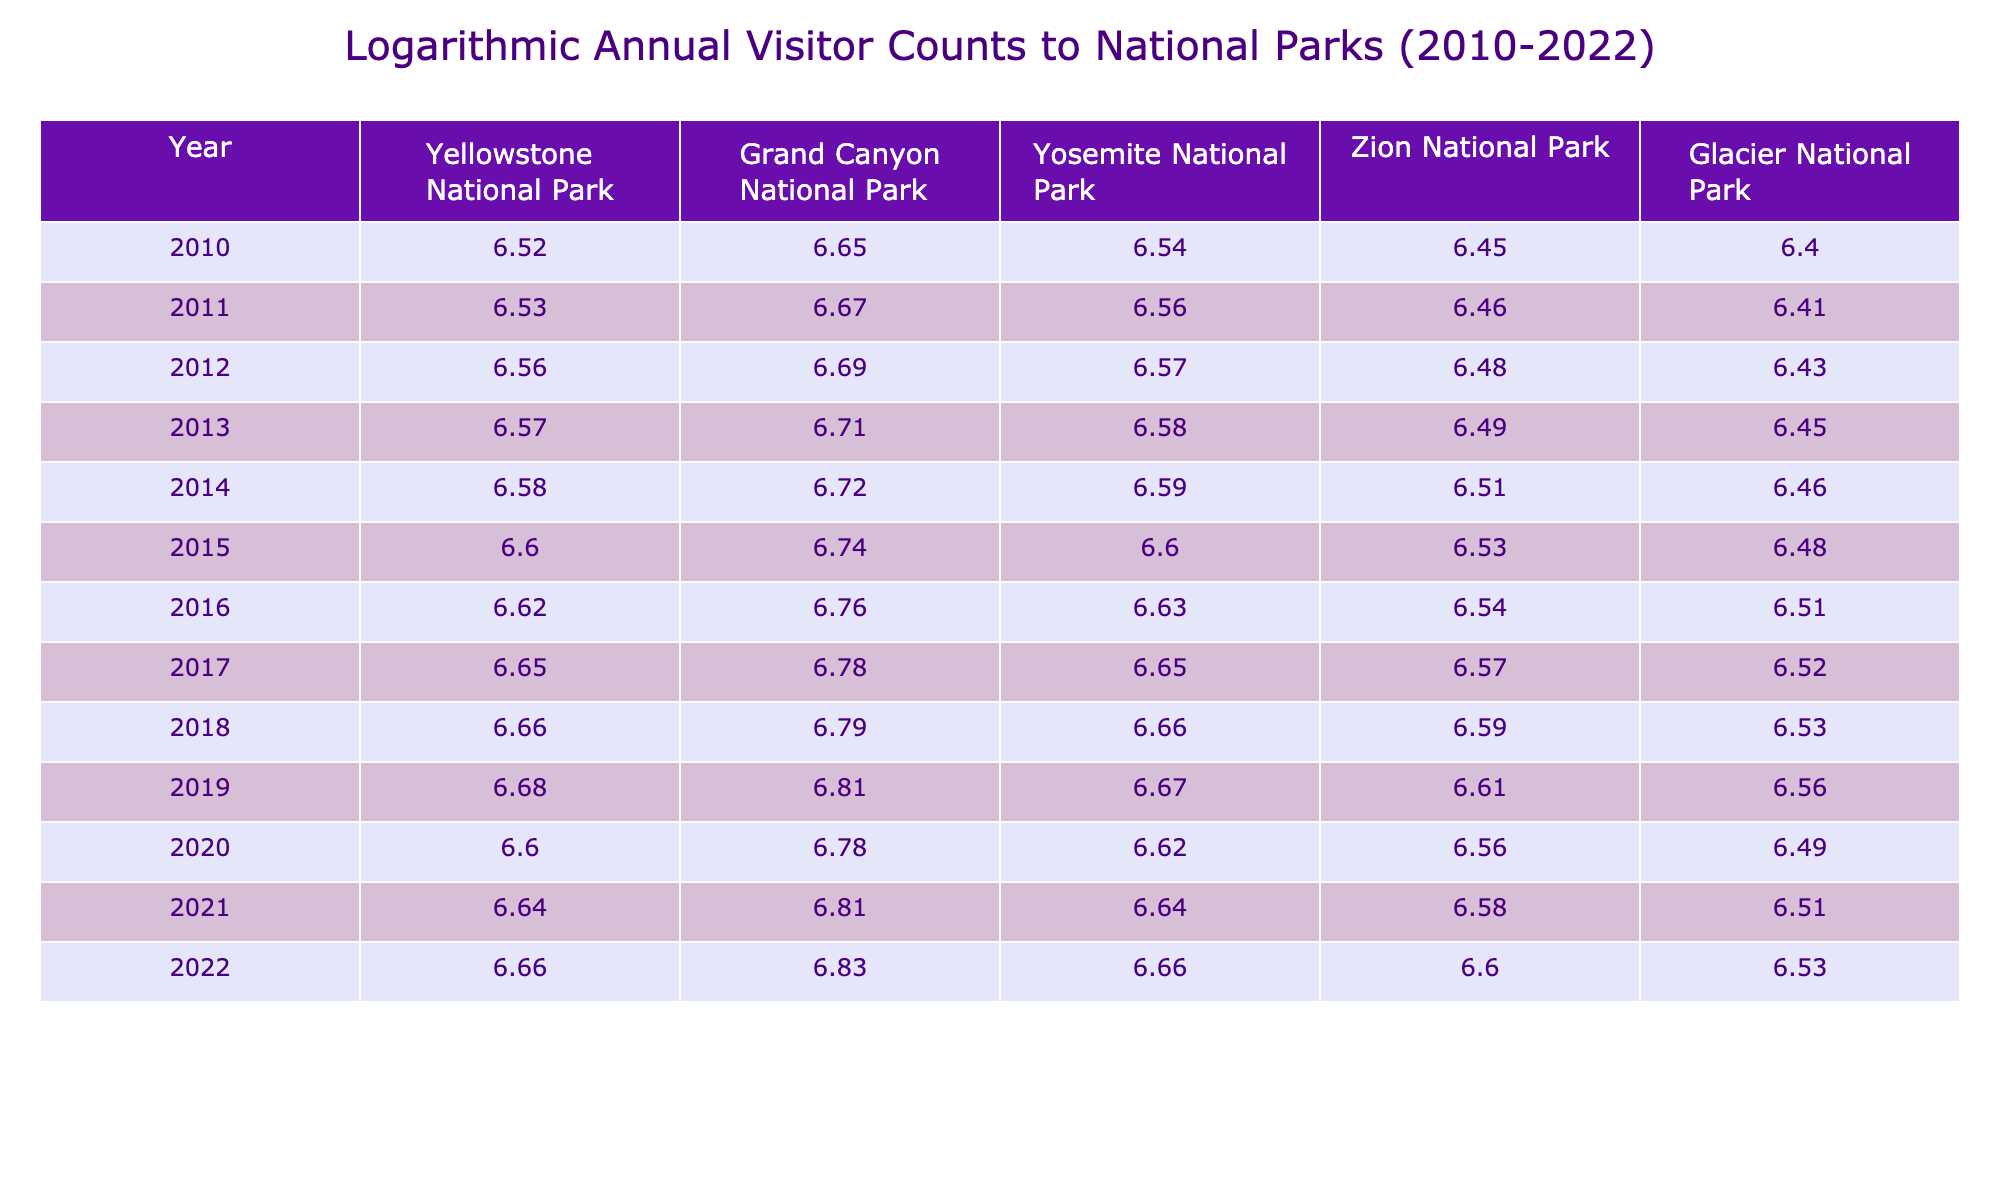What was the visitor count for Yosemite National Park in 2015? In 2015, we can look at the row corresponding to that year in the table, which indicates the logarithmic value for Yosemite National Park as approximately 6.60. The actual visitor count can be deduced from the logarithmic value.
Answer: 4000000 Which national park had the highest visitor count in 2022? By scanning the 2022 row across all national parks, we can see that Grand Canyon National Park has the highest logarithmic value, which corresponds to the highest visitor count. Thus, the park with the highest count is Grand Canyon National Park.
Answer: Grand Canyon National Park What was the average visitor count for all parks combined in 2020? First, we need to find the visitor counts for all parks in 2020, which are Yellowstone (4000000), Grand Canyon (6000000), Yosemite (4200000), Zion (3600000), and Glacier (3100000). Adding these together gives (4000000 + 6000000 + 4200000 + 3600000 + 3100000) = 21000000. Dividing by 5 parks gives us the average: 21000000 / 5 = 4200000.
Answer: 4200000 Did visitor counts for Yellowstone National Park decrease in 2020 compared to 2019? We look at the visitor counts for both years. In 2019, the count is 4800000, and in 2020, it dropped to 4000000. A simple comparison shows that 4000000 is less than 4800000, confirming the decrease in visitors.
Answer: Yes Which national park showed the most significant increase in visitors from 2010 to 2022? For this, we calculate the visitor counts for each park in both years: Yellowstone (3300000 to 4600000), Grand Canyon (4500000 to 6700000), Yosemite (3500000 to 4600000), Zion (2800000 to 4000000), and Glacier (2500000 to 3400000). We find the increase for each park: Yellowstone (1300000), Grand Canyon (2200000), Yosemite (1100000), Zion (1200000), and Glacier (900000). The largest increase is for Grand Canyon, with an increase of 2200000 visitors.
Answer: Grand Canyon National Park 